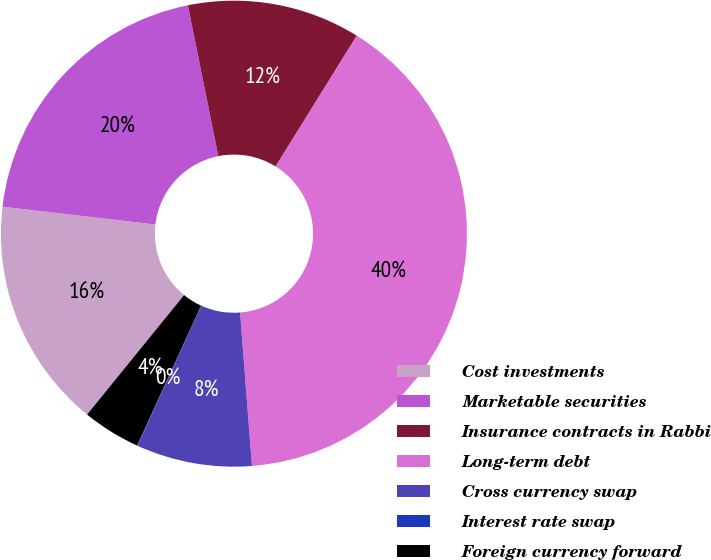<chart> <loc_0><loc_0><loc_500><loc_500><pie_chart><fcel>Cost investments<fcel>Marketable securities<fcel>Insurance contracts in Rabbi<fcel>Long-term debt<fcel>Cross currency swap<fcel>Interest rate swap<fcel>Foreign currency forward<nl><fcel>16.0%<fcel>19.99%<fcel>12.01%<fcel>39.94%<fcel>8.02%<fcel>0.04%<fcel>4.03%<nl></chart> 